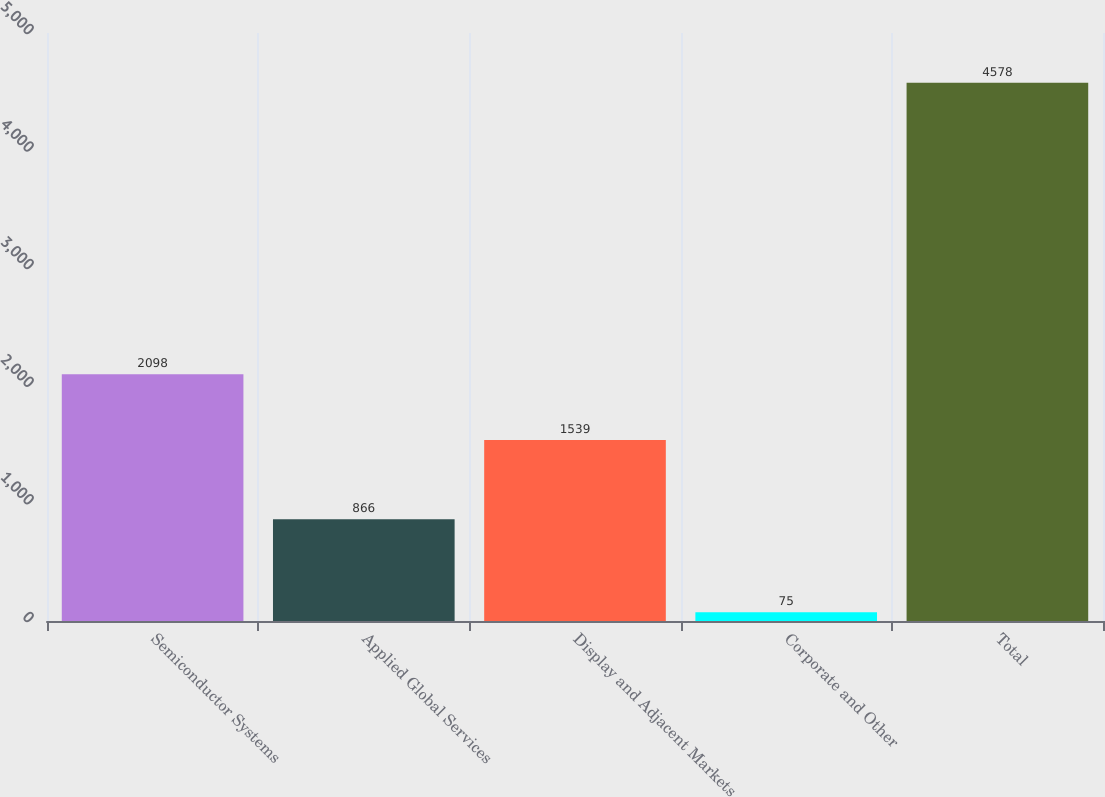<chart> <loc_0><loc_0><loc_500><loc_500><bar_chart><fcel>Semiconductor Systems<fcel>Applied Global Services<fcel>Display and Adjacent Markets<fcel>Corporate and Other<fcel>Total<nl><fcel>2098<fcel>866<fcel>1539<fcel>75<fcel>4578<nl></chart> 